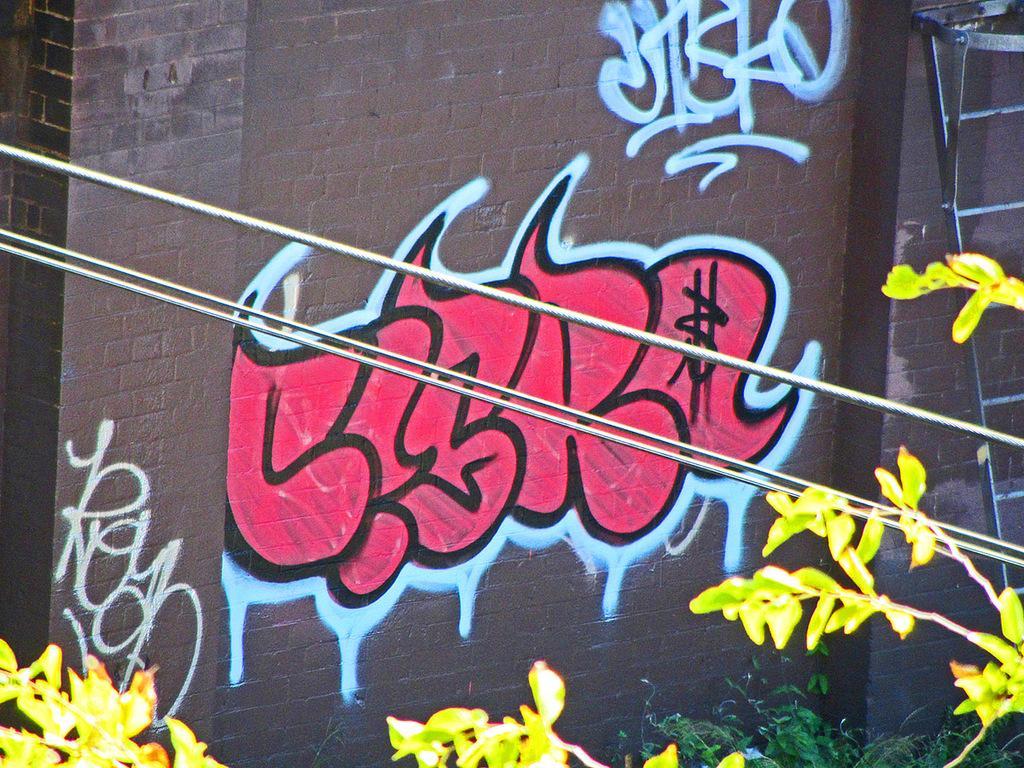In one or two sentences, can you explain what this image depicts? In the image we can see there is graffiti done on the wall of the building and there are plants. There are electrical wires. 